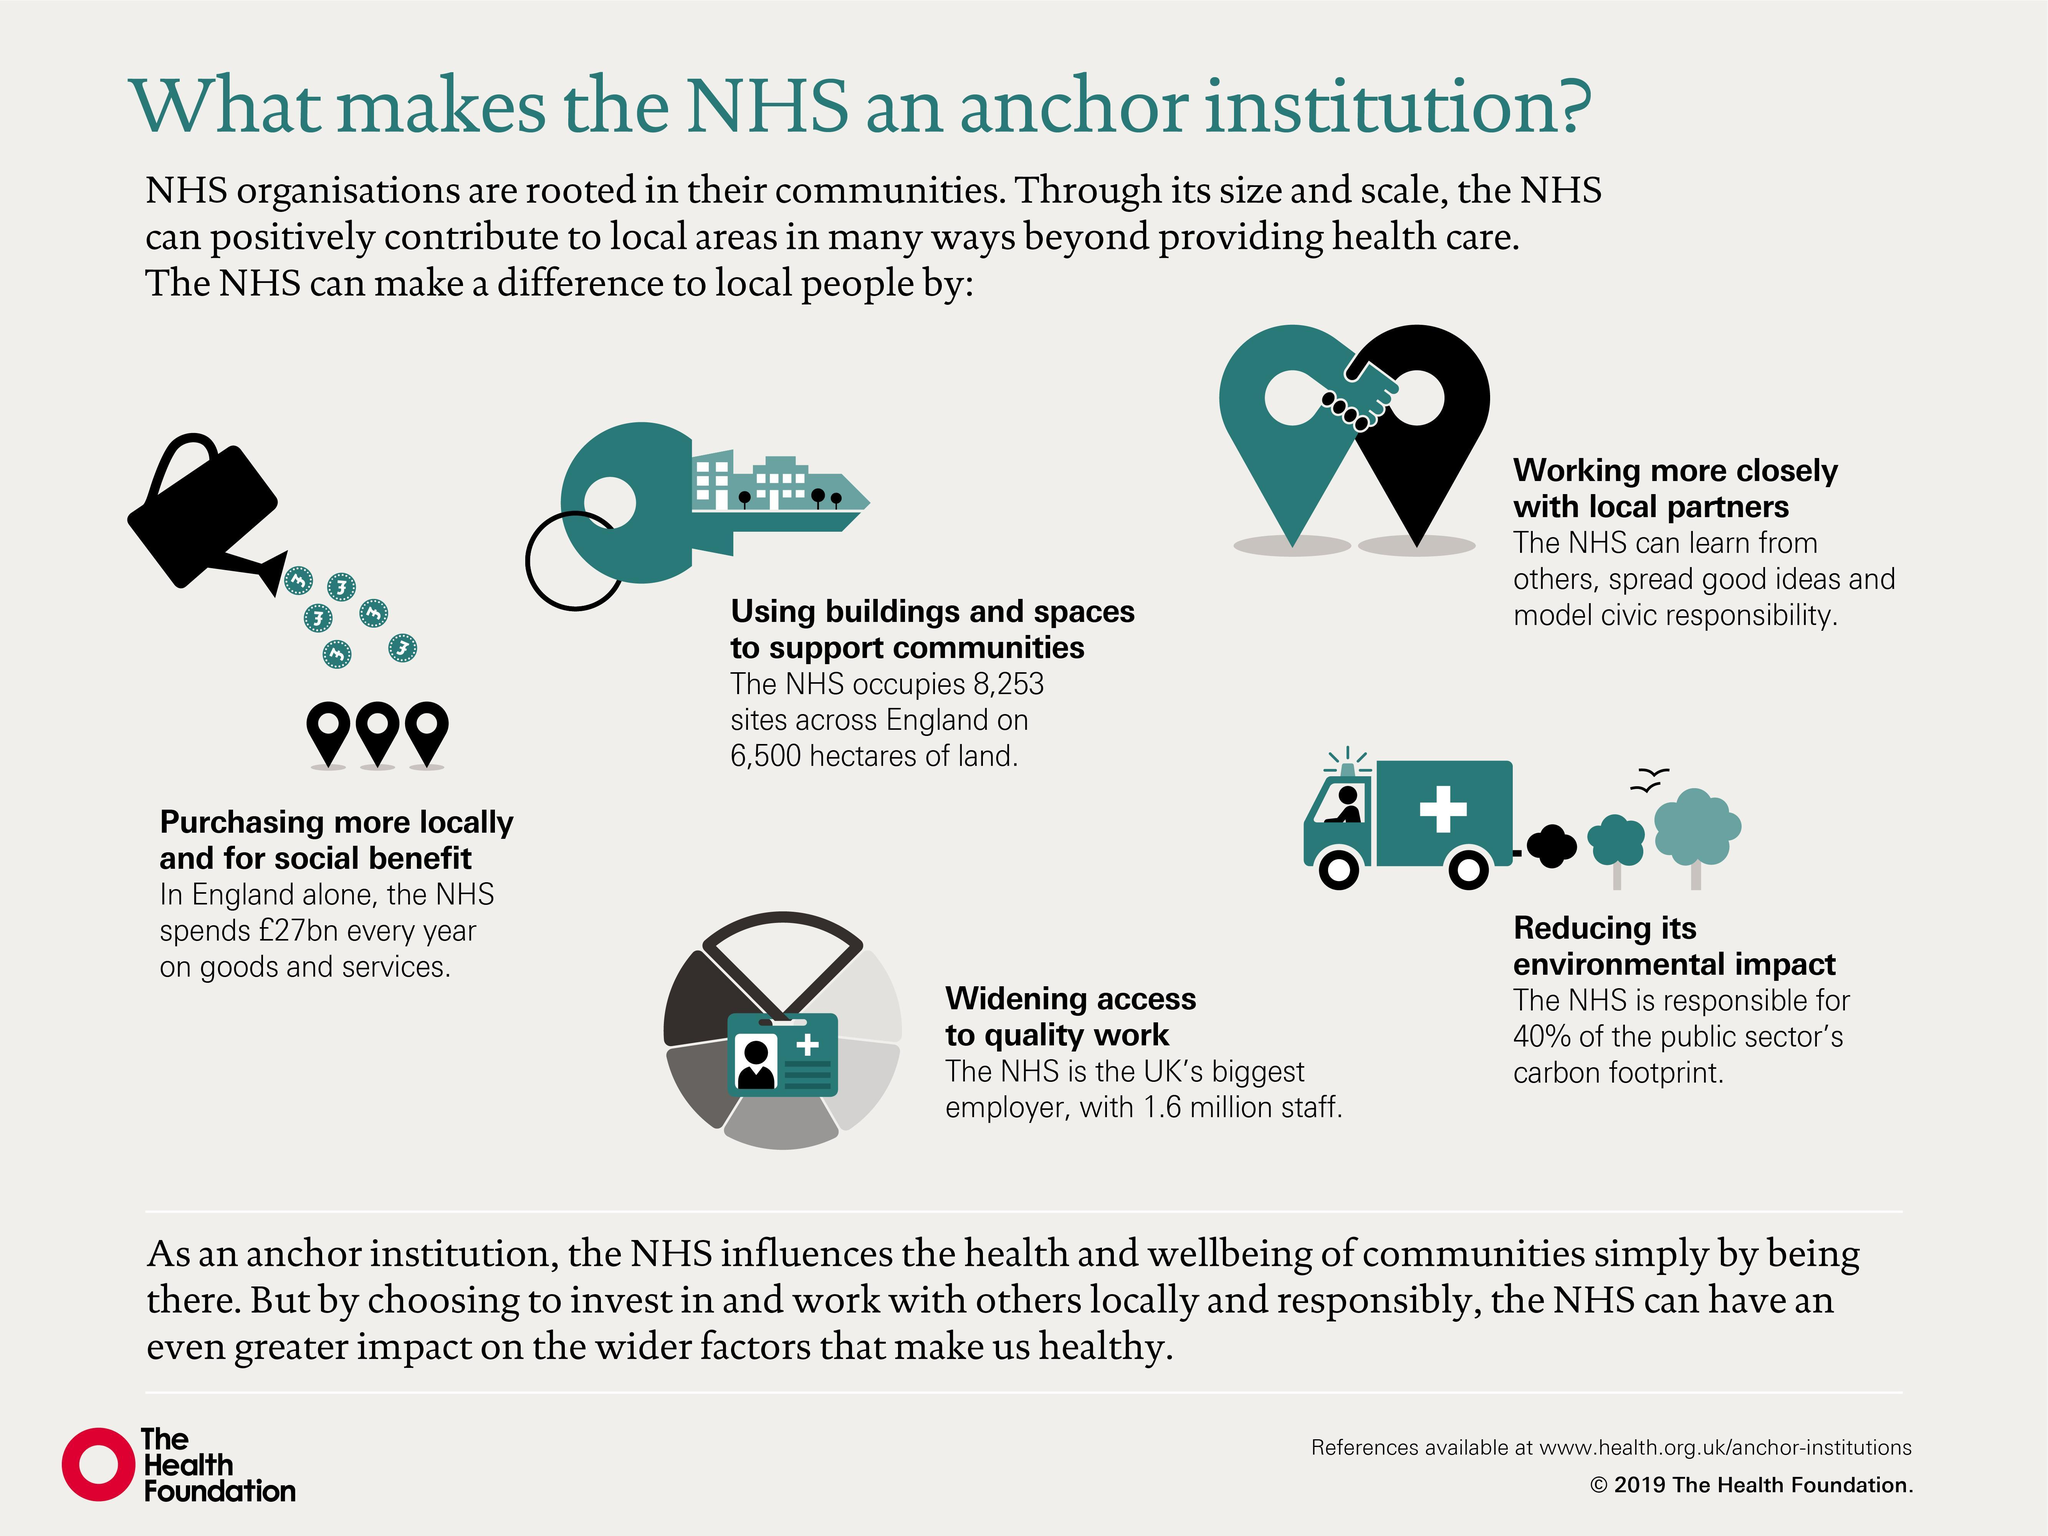How much staff does NHS employ?
Answer the question with a short phrase. 1.6 million Who is responsible for two-fifth of public sector's carbon footprint? NHS 